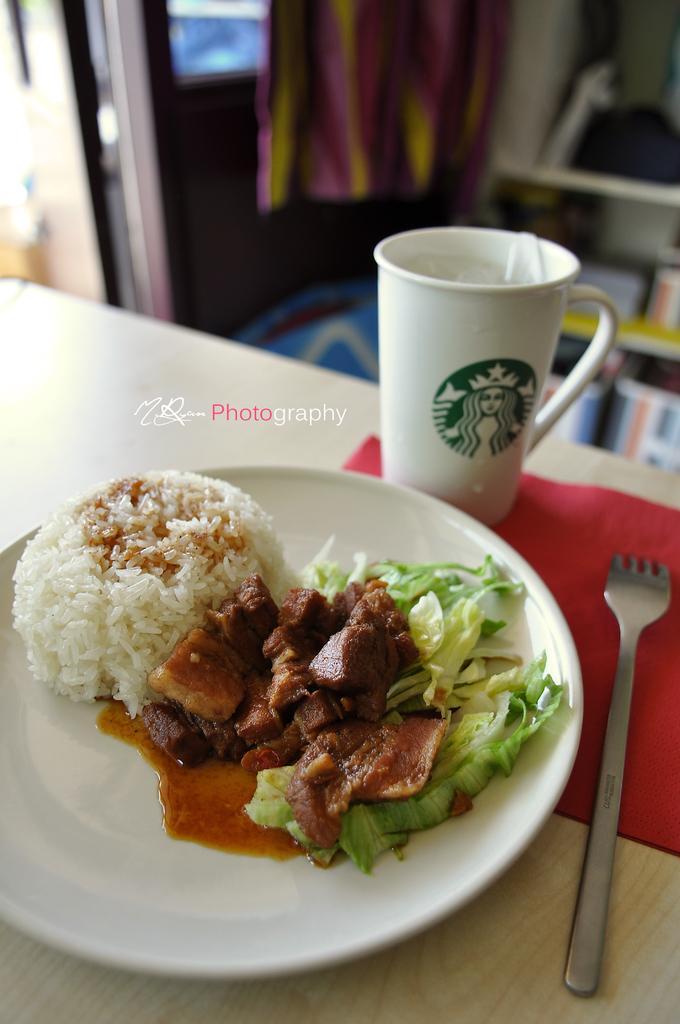In one or two sentences, can you explain what this image depicts? In this image, I can see a cup, fork, food item on a plate and a napkin on the table. In the background, I can see a cloth hanging and few objects. At the center of the image, there is a watermark. 